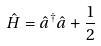<formula> <loc_0><loc_0><loc_500><loc_500>\hat { H } = \hat { a } ^ { \dagger } \hat { a } + \frac { 1 } { 2 }</formula> 